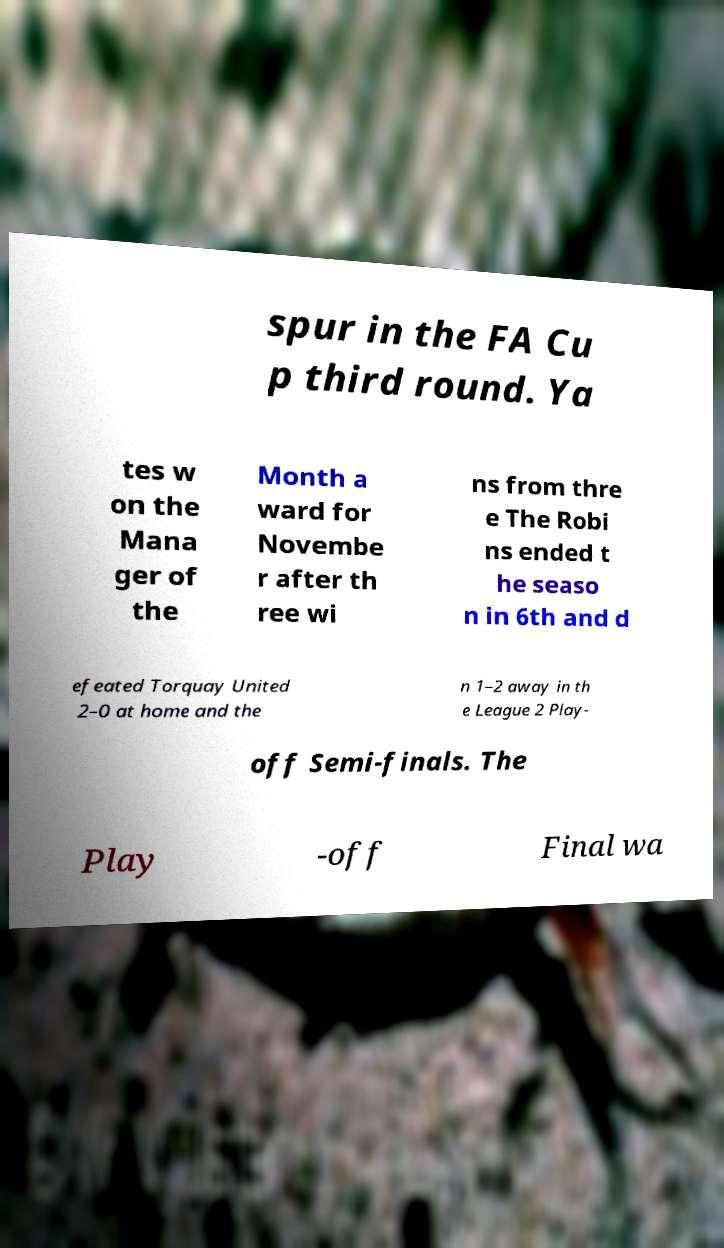Could you extract and type out the text from this image? spur in the FA Cu p third round. Ya tes w on the Mana ger of the Month a ward for Novembe r after th ree wi ns from thre e The Robi ns ended t he seaso n in 6th and d efeated Torquay United 2–0 at home and the n 1–2 away in th e League 2 Play- off Semi-finals. The Play -off Final wa 